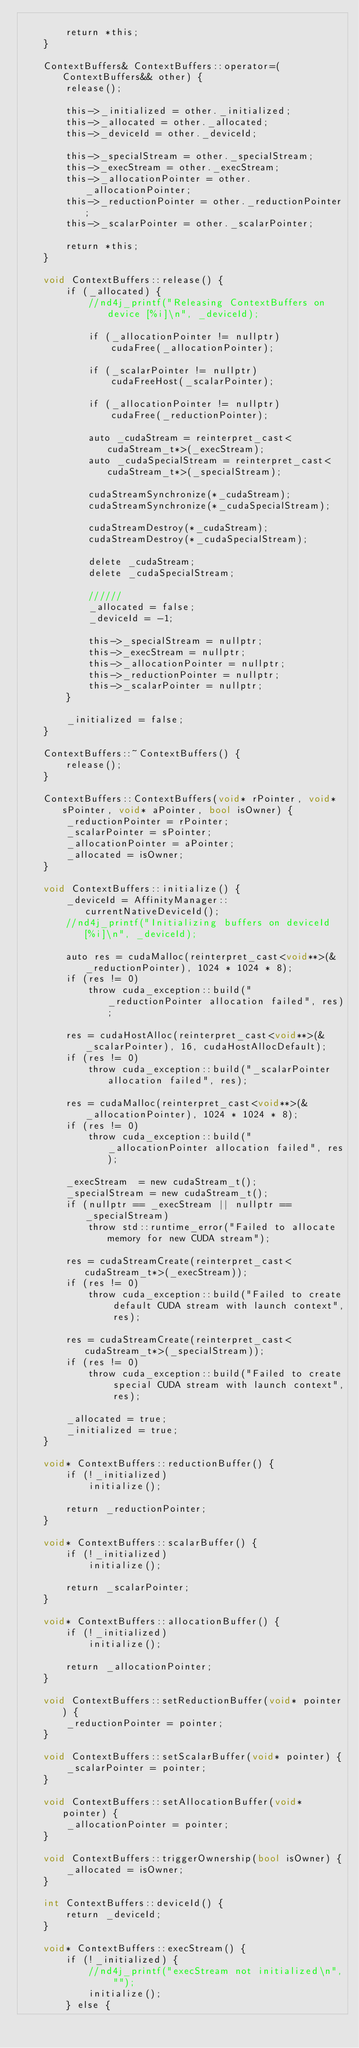Convert code to text. <code><loc_0><loc_0><loc_500><loc_500><_Cuda_>
        return *this;
    }

    ContextBuffers& ContextBuffers::operator=(ContextBuffers&& other) {
        release();

        this->_initialized = other._initialized;
        this->_allocated = other._allocated;
        this->_deviceId = other._deviceId;

        this->_specialStream = other._specialStream;
        this->_execStream = other._execStream;
        this->_allocationPointer = other._allocationPointer;
        this->_reductionPointer = other._reductionPointer;
        this->_scalarPointer = other._scalarPointer;

        return *this;
    }

    void ContextBuffers::release() {
        if (_allocated) {
            //nd4j_printf("Releasing ContextBuffers on device [%i]\n", _deviceId);

            if (_allocationPointer != nullptr)
                cudaFree(_allocationPointer);

            if (_scalarPointer != nullptr)
                cudaFreeHost(_scalarPointer);

            if (_allocationPointer != nullptr)
                cudaFree(_reductionPointer);

            auto _cudaStream = reinterpret_cast<cudaStream_t*>(_execStream);
            auto _cudaSpecialStream = reinterpret_cast<cudaStream_t*>(_specialStream);

            cudaStreamSynchronize(*_cudaStream);
            cudaStreamSynchronize(*_cudaSpecialStream);

            cudaStreamDestroy(*_cudaStream);
            cudaStreamDestroy(*_cudaSpecialStream);

            delete _cudaStream;
            delete _cudaSpecialStream;

            //////
            _allocated = false;
            _deviceId = -1;

            this->_specialStream = nullptr;
            this->_execStream = nullptr;
            this->_allocationPointer = nullptr;
            this->_reductionPointer = nullptr;
            this->_scalarPointer = nullptr;
        }

        _initialized = false;
    }

    ContextBuffers::~ContextBuffers() {
        release();
    }

    ContextBuffers::ContextBuffers(void* rPointer, void* sPointer, void* aPointer, bool isOwner) {
        _reductionPointer = rPointer;
        _scalarPointer = sPointer;
        _allocationPointer = aPointer;
        _allocated = isOwner;
    }

    void ContextBuffers::initialize() {
        _deviceId = AffinityManager::currentNativeDeviceId();
        //nd4j_printf("Initializing buffers on deviceId [%i]\n", _deviceId);

        auto res = cudaMalloc(reinterpret_cast<void**>(&_reductionPointer), 1024 * 1024 * 8);
        if (res != 0)
            throw cuda_exception::build("_reductionPointer allocation failed", res);

        res = cudaHostAlloc(reinterpret_cast<void**>(&_scalarPointer), 16, cudaHostAllocDefault);
        if (res != 0)
            throw cuda_exception::build("_scalarPointer allocation failed", res);

        res = cudaMalloc(reinterpret_cast<void**>(&_allocationPointer), 1024 * 1024 * 8);
        if (res != 0)
            throw cuda_exception::build("_allocationPointer allocation failed", res);

        _execStream  = new cudaStream_t();
        _specialStream = new cudaStream_t();
        if (nullptr == _execStream || nullptr == _specialStream)
            throw std::runtime_error("Failed to allocate memory for new CUDA stream");

        res = cudaStreamCreate(reinterpret_cast<cudaStream_t*>(_execStream));
        if (res != 0)
            throw cuda_exception::build("Failed to create default CUDA stream with launch context", res);

        res = cudaStreamCreate(reinterpret_cast<cudaStream_t*>(_specialStream));
        if (res != 0)
            throw cuda_exception::build("Failed to create special CUDA stream with launch context", res);

        _allocated = true;
        _initialized = true;
    }

    void* ContextBuffers::reductionBuffer() {
        if (!_initialized)
            initialize();

        return _reductionPointer;
    }

    void* ContextBuffers::scalarBuffer() {
        if (!_initialized)
            initialize();

        return _scalarPointer;
    }

    void* ContextBuffers::allocationBuffer() {
        if (!_initialized)
            initialize();

        return _allocationPointer;
    }

    void ContextBuffers::setReductionBuffer(void* pointer) {
        _reductionPointer = pointer;
    }

    void ContextBuffers::setScalarBuffer(void* pointer) {
        _scalarPointer = pointer;
    }

    void ContextBuffers::setAllocationBuffer(void* pointer) {
        _allocationPointer = pointer;
    }

    void ContextBuffers::triggerOwnership(bool isOwner) {
        _allocated = isOwner;
    }

    int ContextBuffers::deviceId() {
        return _deviceId;
    }

    void* ContextBuffers::execStream() {
        if (!_initialized) {
            //nd4j_printf("execStream not initialized\n", "");
            initialize();
        } else {</code> 